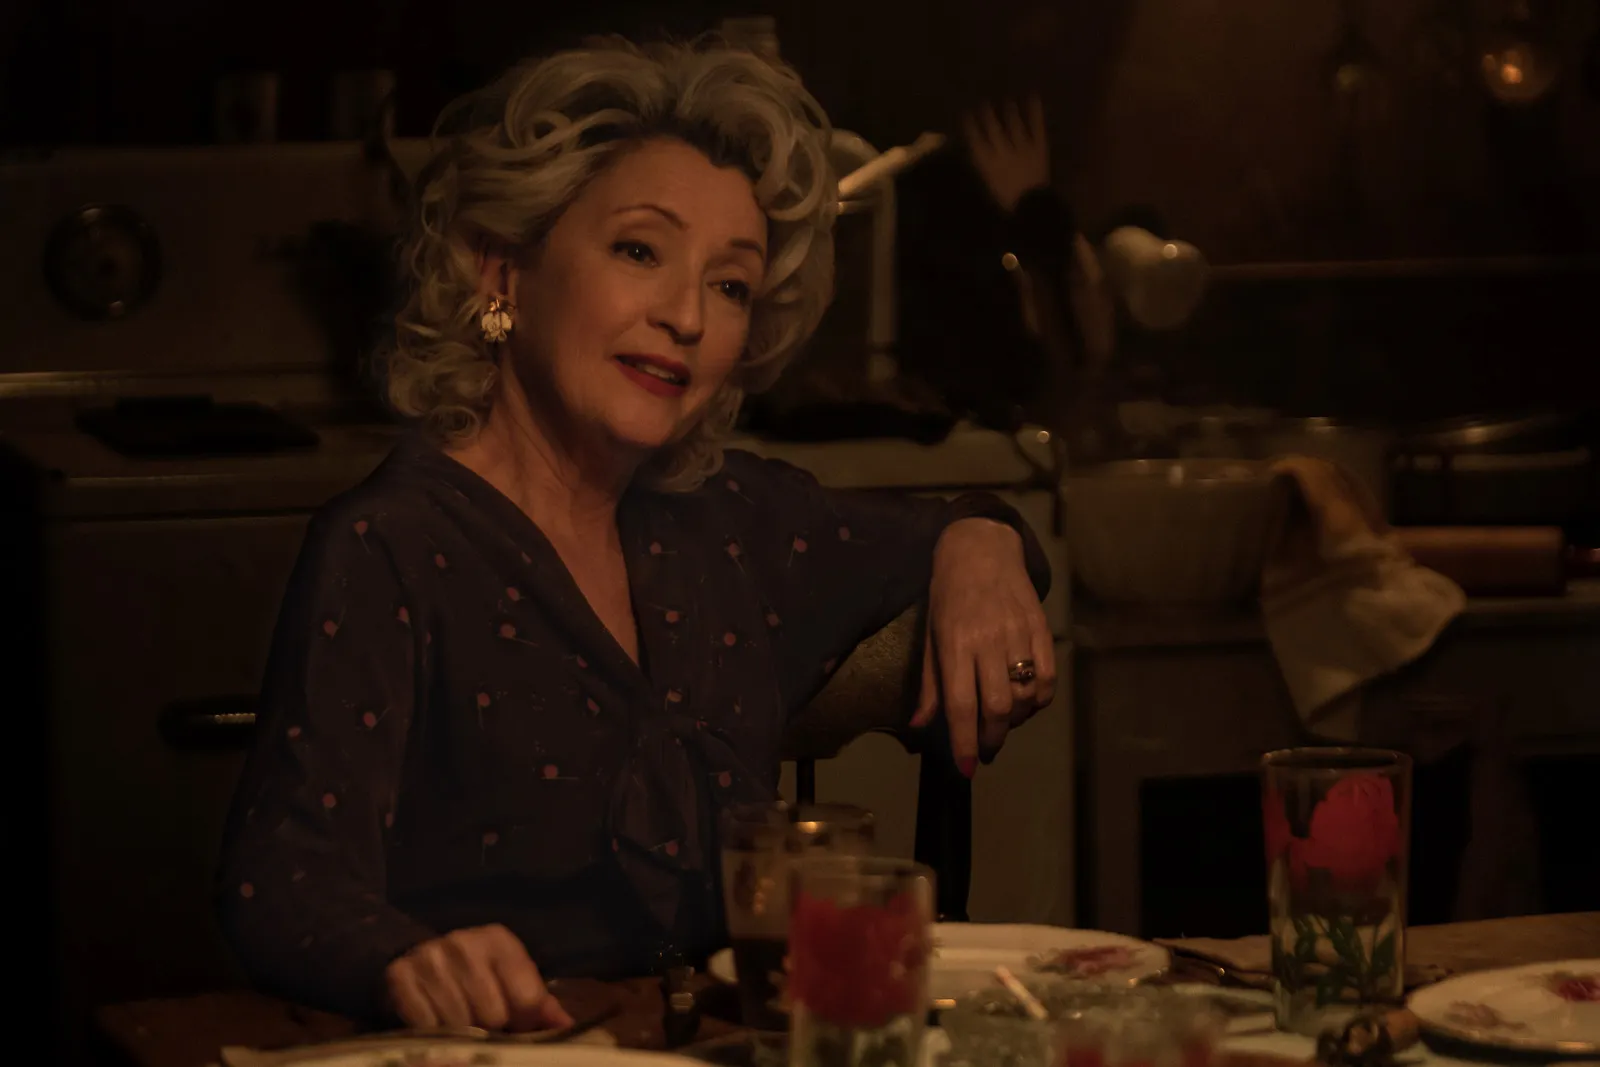Describe the atmosphere of the kitchen visible in the background. The kitchen exhibits a cozy and inviting atmosphere with its dimly lit surroundings, highlighted by the warm glow of the overhead lights. The presence of cooking utensils and a pot on the stove suggest that it is a functional space, likely used frequently for preparing meals. The overall rustic decor coupled with practical kitchenware creates a lived-in feel, portraying a setting that is both charming and utilitarian. 